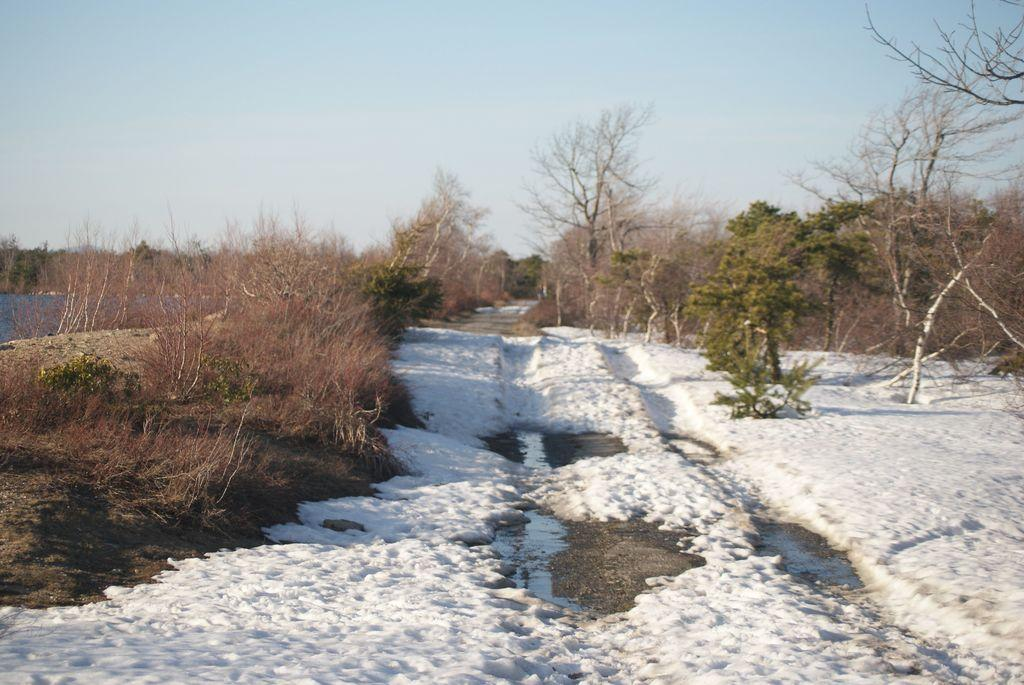What is covering the surface in the image? There is snow on the surface in the image. What type of vegetation can be seen in the image? Trees are present in the image. What type of pickle is being cooked in the image? There is no pickle or cooking activity present in the image; it features snow and trees. 